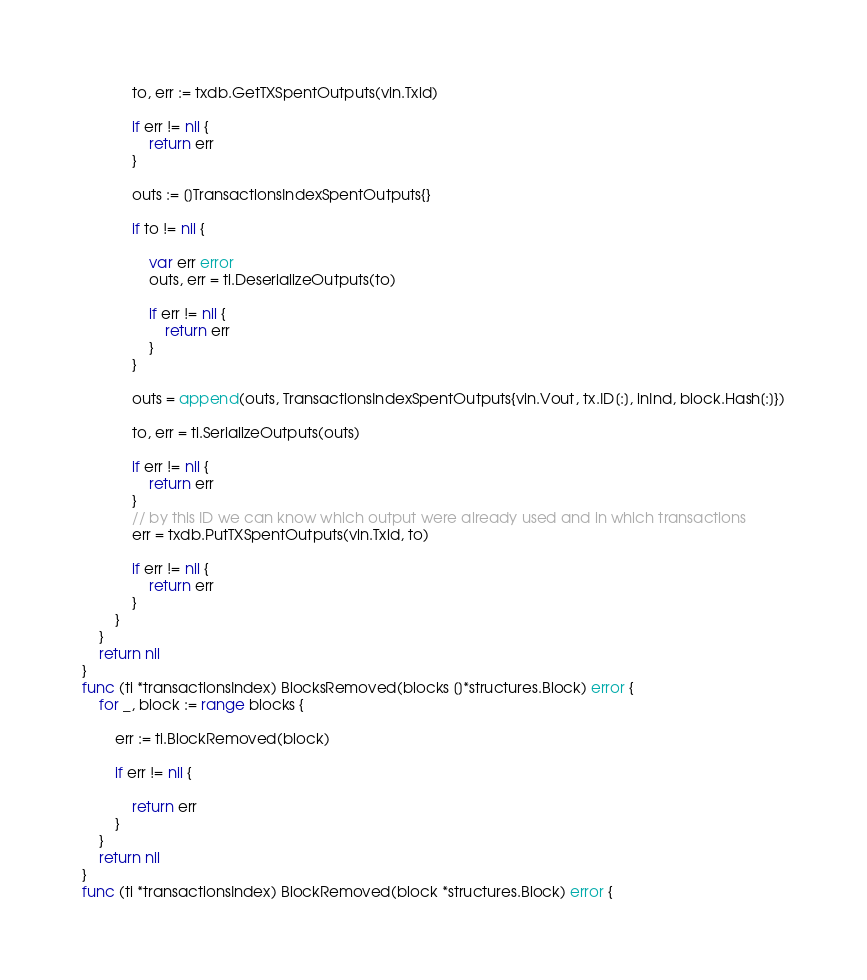<code> <loc_0><loc_0><loc_500><loc_500><_Go_>			to, err := txdb.GetTXSpentOutputs(vin.Txid)

			if err != nil {
				return err
			}

			outs := []TransactionsIndexSpentOutputs{}

			if to != nil {

				var err error
				outs, err = ti.DeserializeOutputs(to)

				if err != nil {
					return err
				}
			}

			outs = append(outs, TransactionsIndexSpentOutputs{vin.Vout, tx.ID[:], inInd, block.Hash[:]})

			to, err = ti.SerializeOutputs(outs)

			if err != nil {
				return err
			}
			// by this ID we can know which output were already used and in which transactions
			err = txdb.PutTXSpentOutputs(vin.Txid, to)

			if err != nil {
				return err
			}
		}
	}
	return nil
}
func (ti *transactionsIndex) BlocksRemoved(blocks []*structures.Block) error {
	for _, block := range blocks {

		err := ti.BlockRemoved(block)

		if err != nil {

			return err
		}
	}
	return nil
}
func (ti *transactionsIndex) BlockRemoved(block *structures.Block) error {</code> 